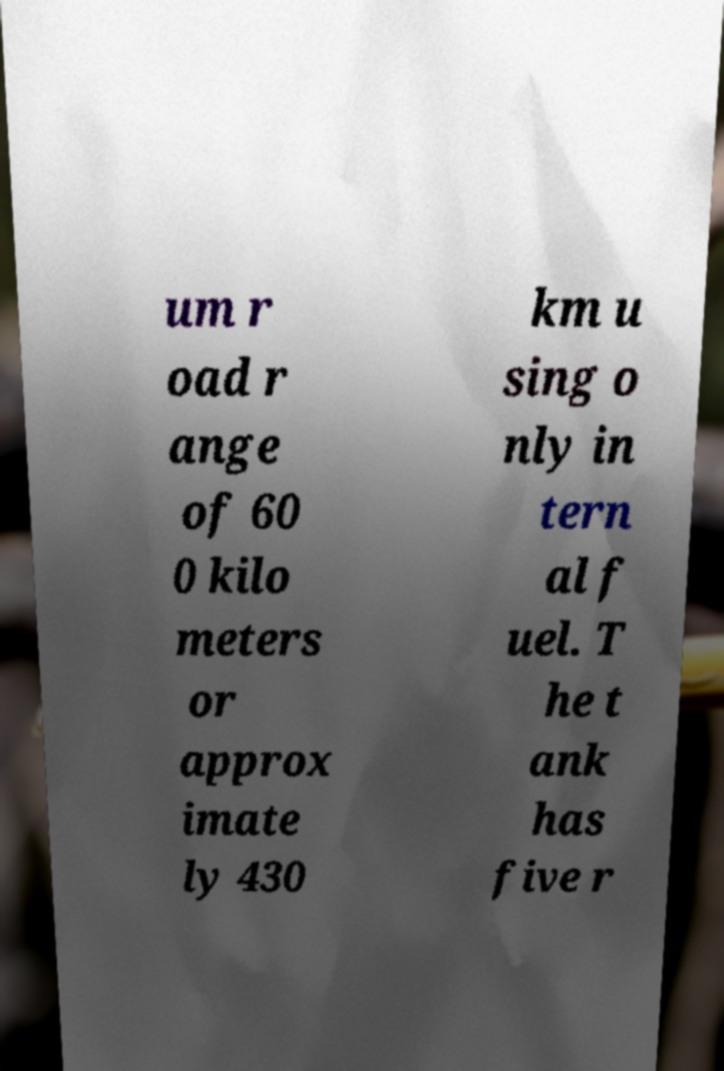Can you read and provide the text displayed in the image?This photo seems to have some interesting text. Can you extract and type it out for me? um r oad r ange of 60 0 kilo meters or approx imate ly 430 km u sing o nly in tern al f uel. T he t ank has five r 